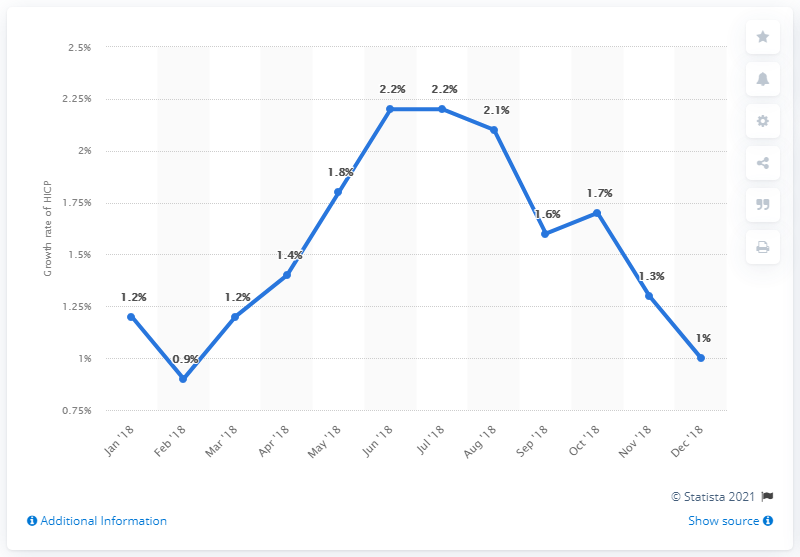Specify some key components in this picture. The growth rate of HICP in December 2018 was 1%. In June and July of 2018, the growth rate of the Harmonized Index of Consumer Prices (HICP) was 2.2 percent. 